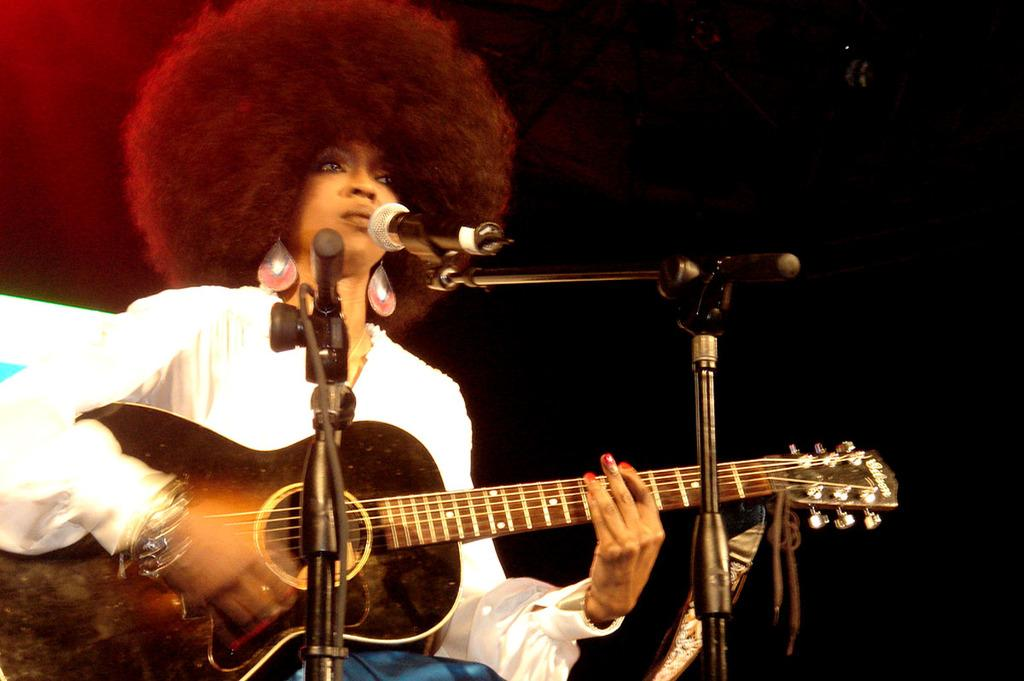What is the main subject of the image? The main subject of the image is a woman. What is the woman doing in the image? The woman is standing and playing a guitar. What object is present in the image that is typically used for amplifying sound? There is a mic in the image. How is the mic positioned in the image? The mic is attached to a mike stand. What type of fire can be seen burning in the image? There is no fire present in the image. What is the woman using to attach the mic to the mike stand in the image? The woman is not using any glue to attach the mic to the mike stand; it is already attached. What time of day is it in the image? The provided facts do not give any information about the time of day in the image. 